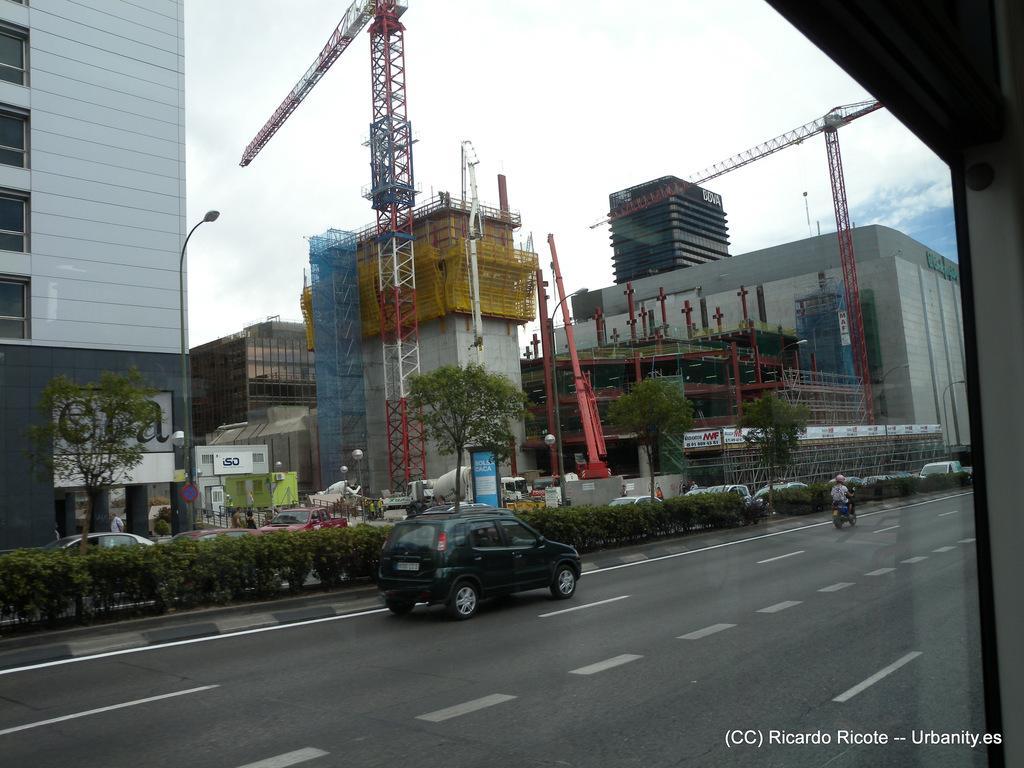Can you describe this image briefly? On the right side, there is a glass window. In the right bottom corner, there is a watermark. Through this glass window we can see, there are vehicles on the road, there are plants on the divider, there are vehicles on the other road, there are trees, buildings, towers and clouds in the sky. 